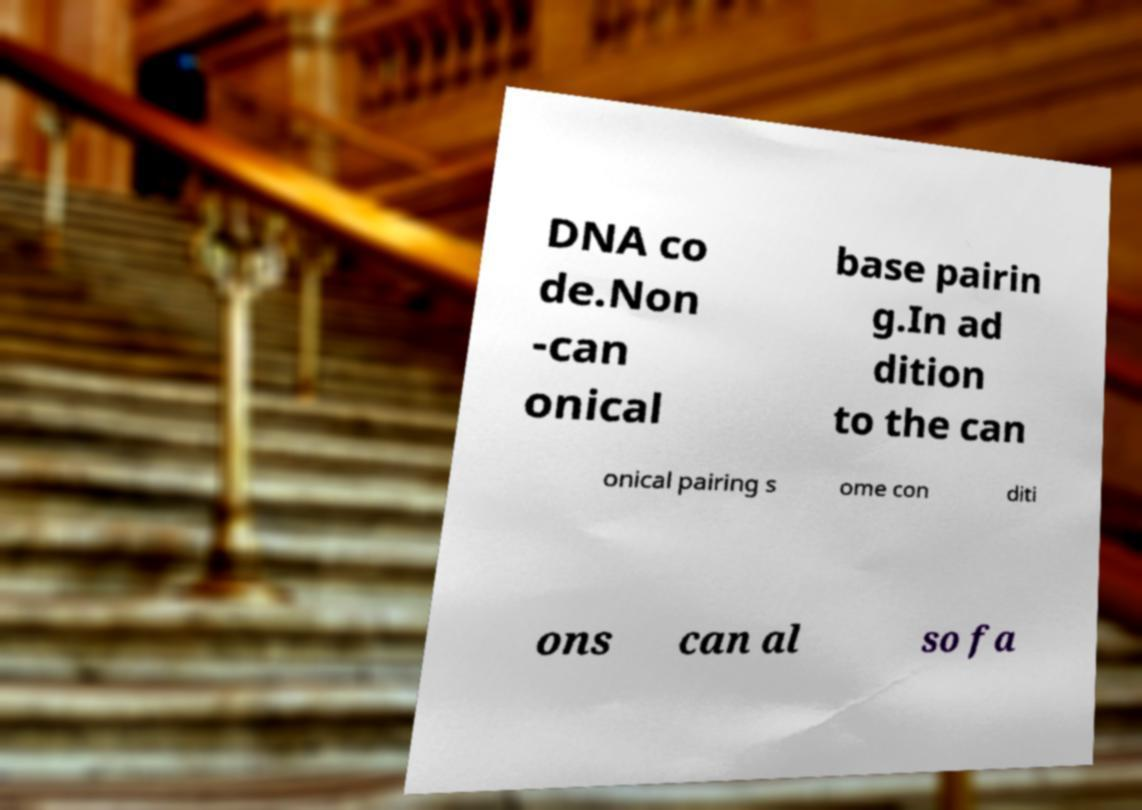What messages or text are displayed in this image? I need them in a readable, typed format. DNA co de.Non -can onical base pairin g.In ad dition to the can onical pairing s ome con diti ons can al so fa 